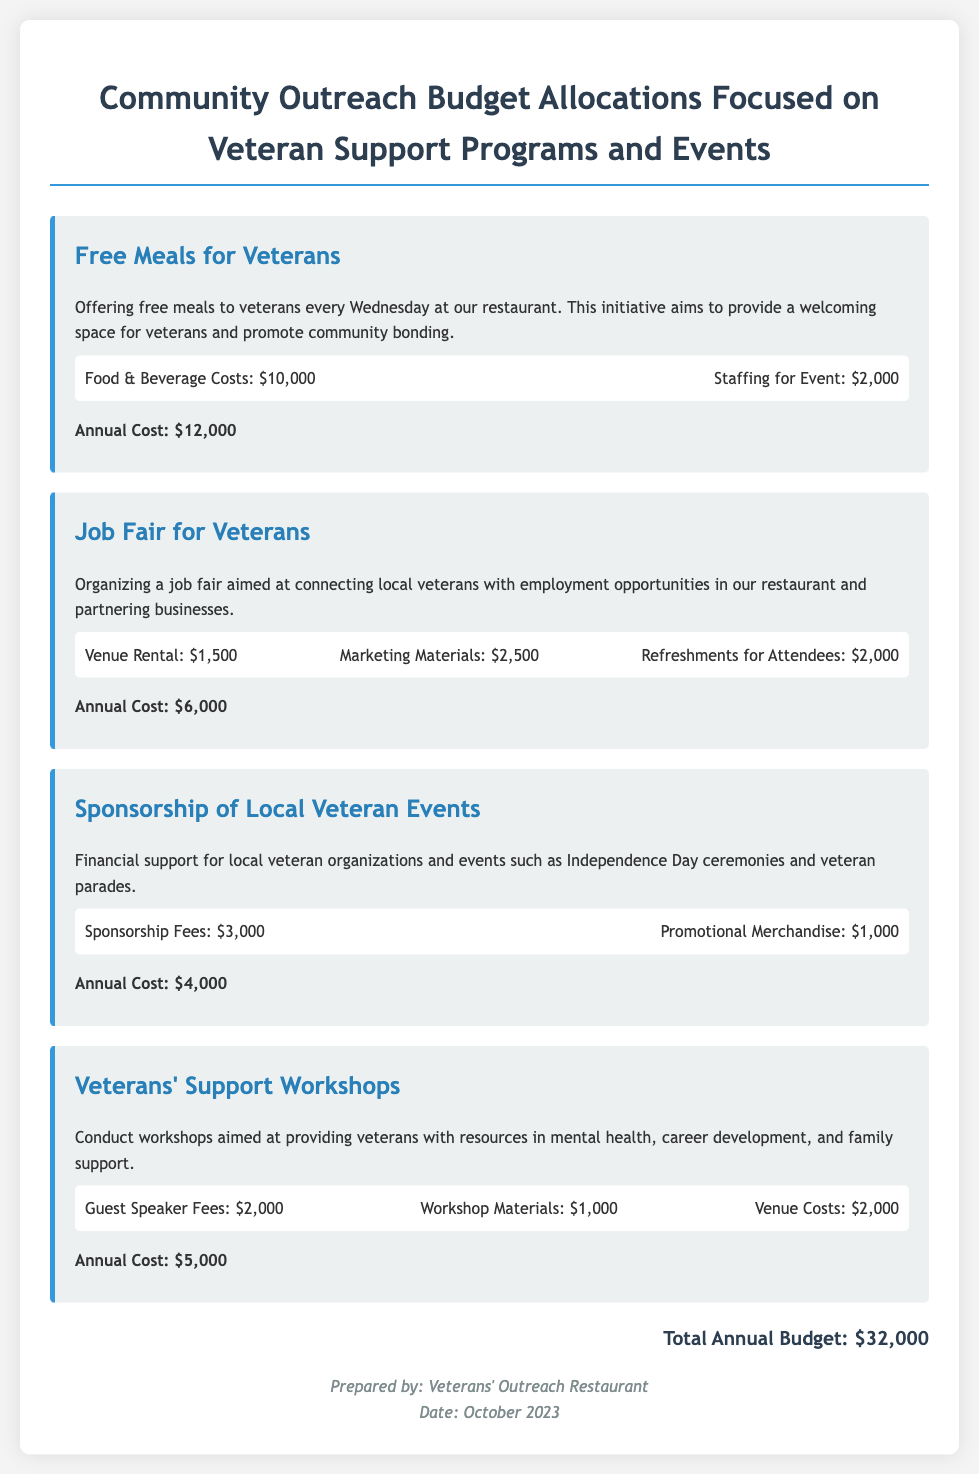What is the total annual budget? The total annual budget is summarized at the end of the document.
Answer: $32,000 How much does the job fair contribute to the annual budget? The document lists the annual cost of the job fair to find its contribution.
Answer: $6,000 What is the purpose of the free meals for veterans? The purpose is explained in the description of the budget item related to free meals.
Answer: Provide a welcoming space for veterans What are the total costs for the Veterans' Support Workshops? The annual cost of the workshops can be found in the workshops section of the document.
Answer: $5,000 What are the food and beverage costs associated with free meals for veterans? The food and beverage costs can be directly retrieved from the budget item details.
Answer: $10,000 How much is allocated for promotional merchandise under sponsorship? The sponsorship section specifies the amount allocated for promotional merchandise.
Answer: $1,000 What is the total refreshment cost for attendees at the job fair? This amount is specified in the budget details for the job fair section.
Answer: $2,000 How many workshops are planned under the veterans' support initiative? The document does not specify a number but relates to the initiative's offerings.
Answer: Not specified What is included in the marketing materials for the job fair? The document describes the job fair's budget items but does not list specifics for marketing materials.
Answer: Not specified 